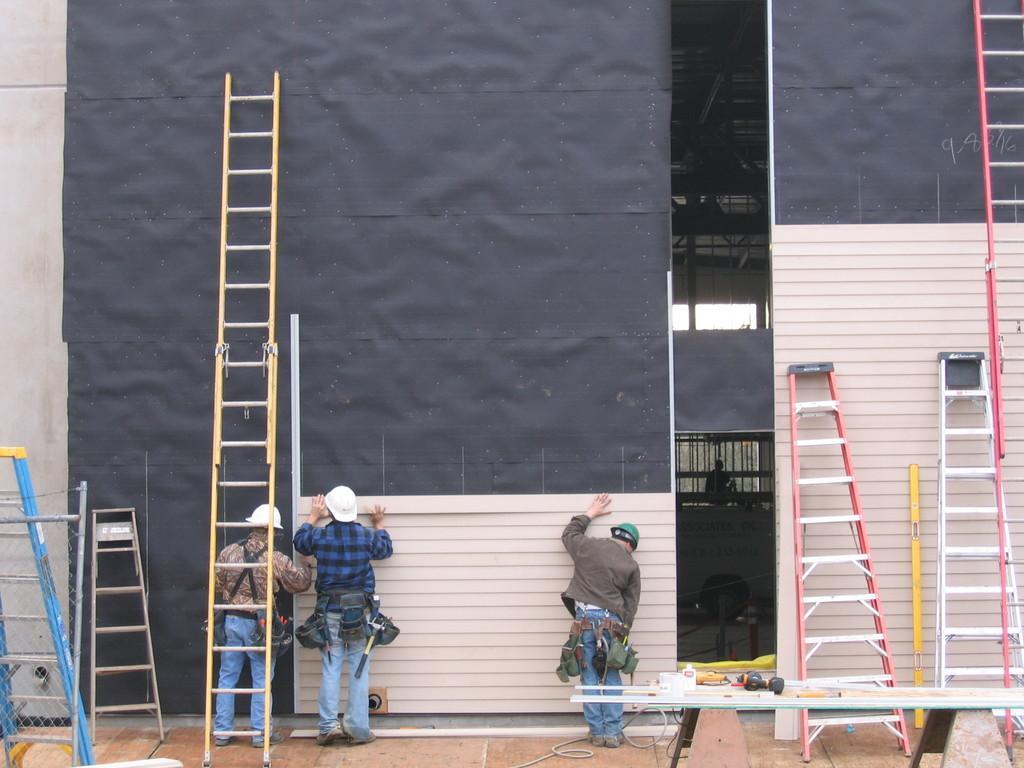How would you summarize this image in a sentence or two? wrbl pl This picture is clicked outside. In the foreground we can see a table on the top of which some items are placed and we can see the ladders and the three persons wearing helmets, standing on the ground and working. In the background there is a wall, roof, black color objects and planks. 